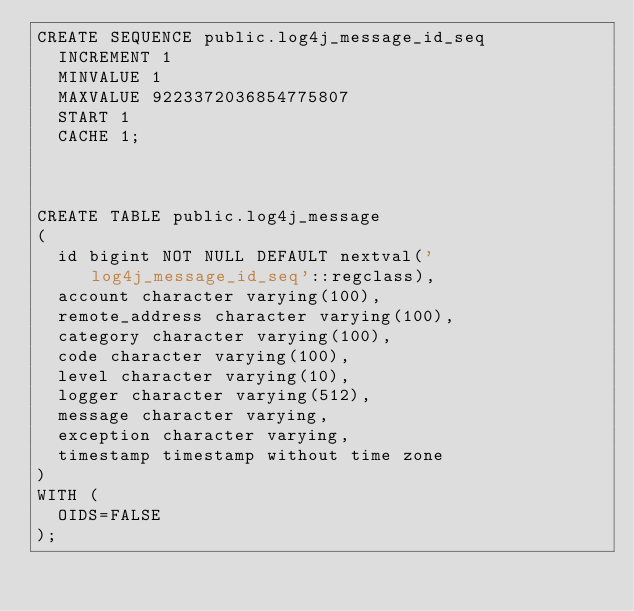Convert code to text. <code><loc_0><loc_0><loc_500><loc_500><_SQL_>CREATE SEQUENCE public.log4j_message_id_seq
  INCREMENT 1
  MINVALUE 1
  MAXVALUE 9223372036854775807
  START 1
  CACHE 1;



CREATE TABLE public.log4j_message
(
  id bigint NOT NULL DEFAULT nextval('log4j_message_id_seq'::regclass),
  account character varying(100),
  remote_address character varying(100),
  category character varying(100),
  code character varying(100),
  level character varying(10),
  logger character varying(512),
  message character varying,
  exception character varying,
  timestamp timestamp without time zone
)
WITH (
  OIDS=FALSE
);
</code> 